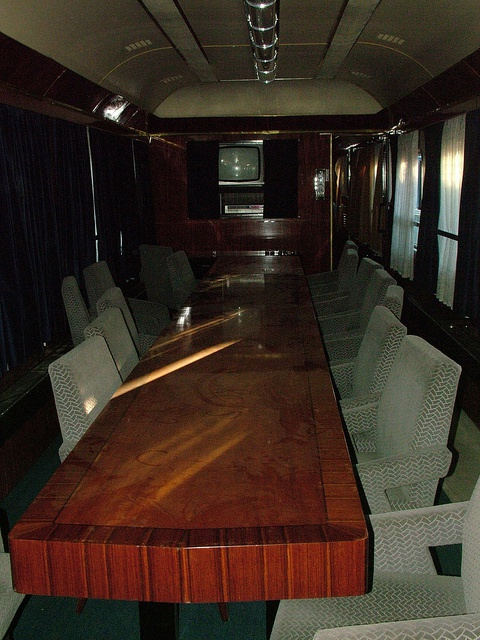Describe the objects in this image and their specific colors. I can see dining table in gray, maroon, and black tones, chair in gray and black tones, chair in gray, darkgreen, and black tones, chair in gray, black, and darkgreen tones, and chair in gray, darkgreen, and black tones in this image. 